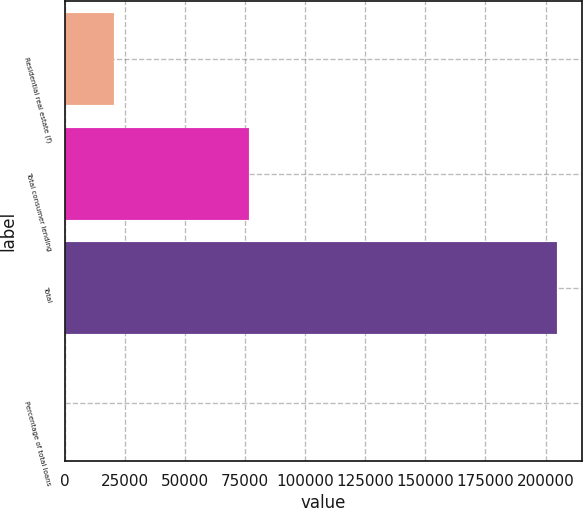Convert chart. <chart><loc_0><loc_0><loc_500><loc_500><bar_chart><fcel>Residential real estate (f)<fcel>Total consumer lending<fcel>Total<fcel>Percentage of total loans<nl><fcel>20571.7<fcel>76449<fcel>204817<fcel>100<nl></chart> 